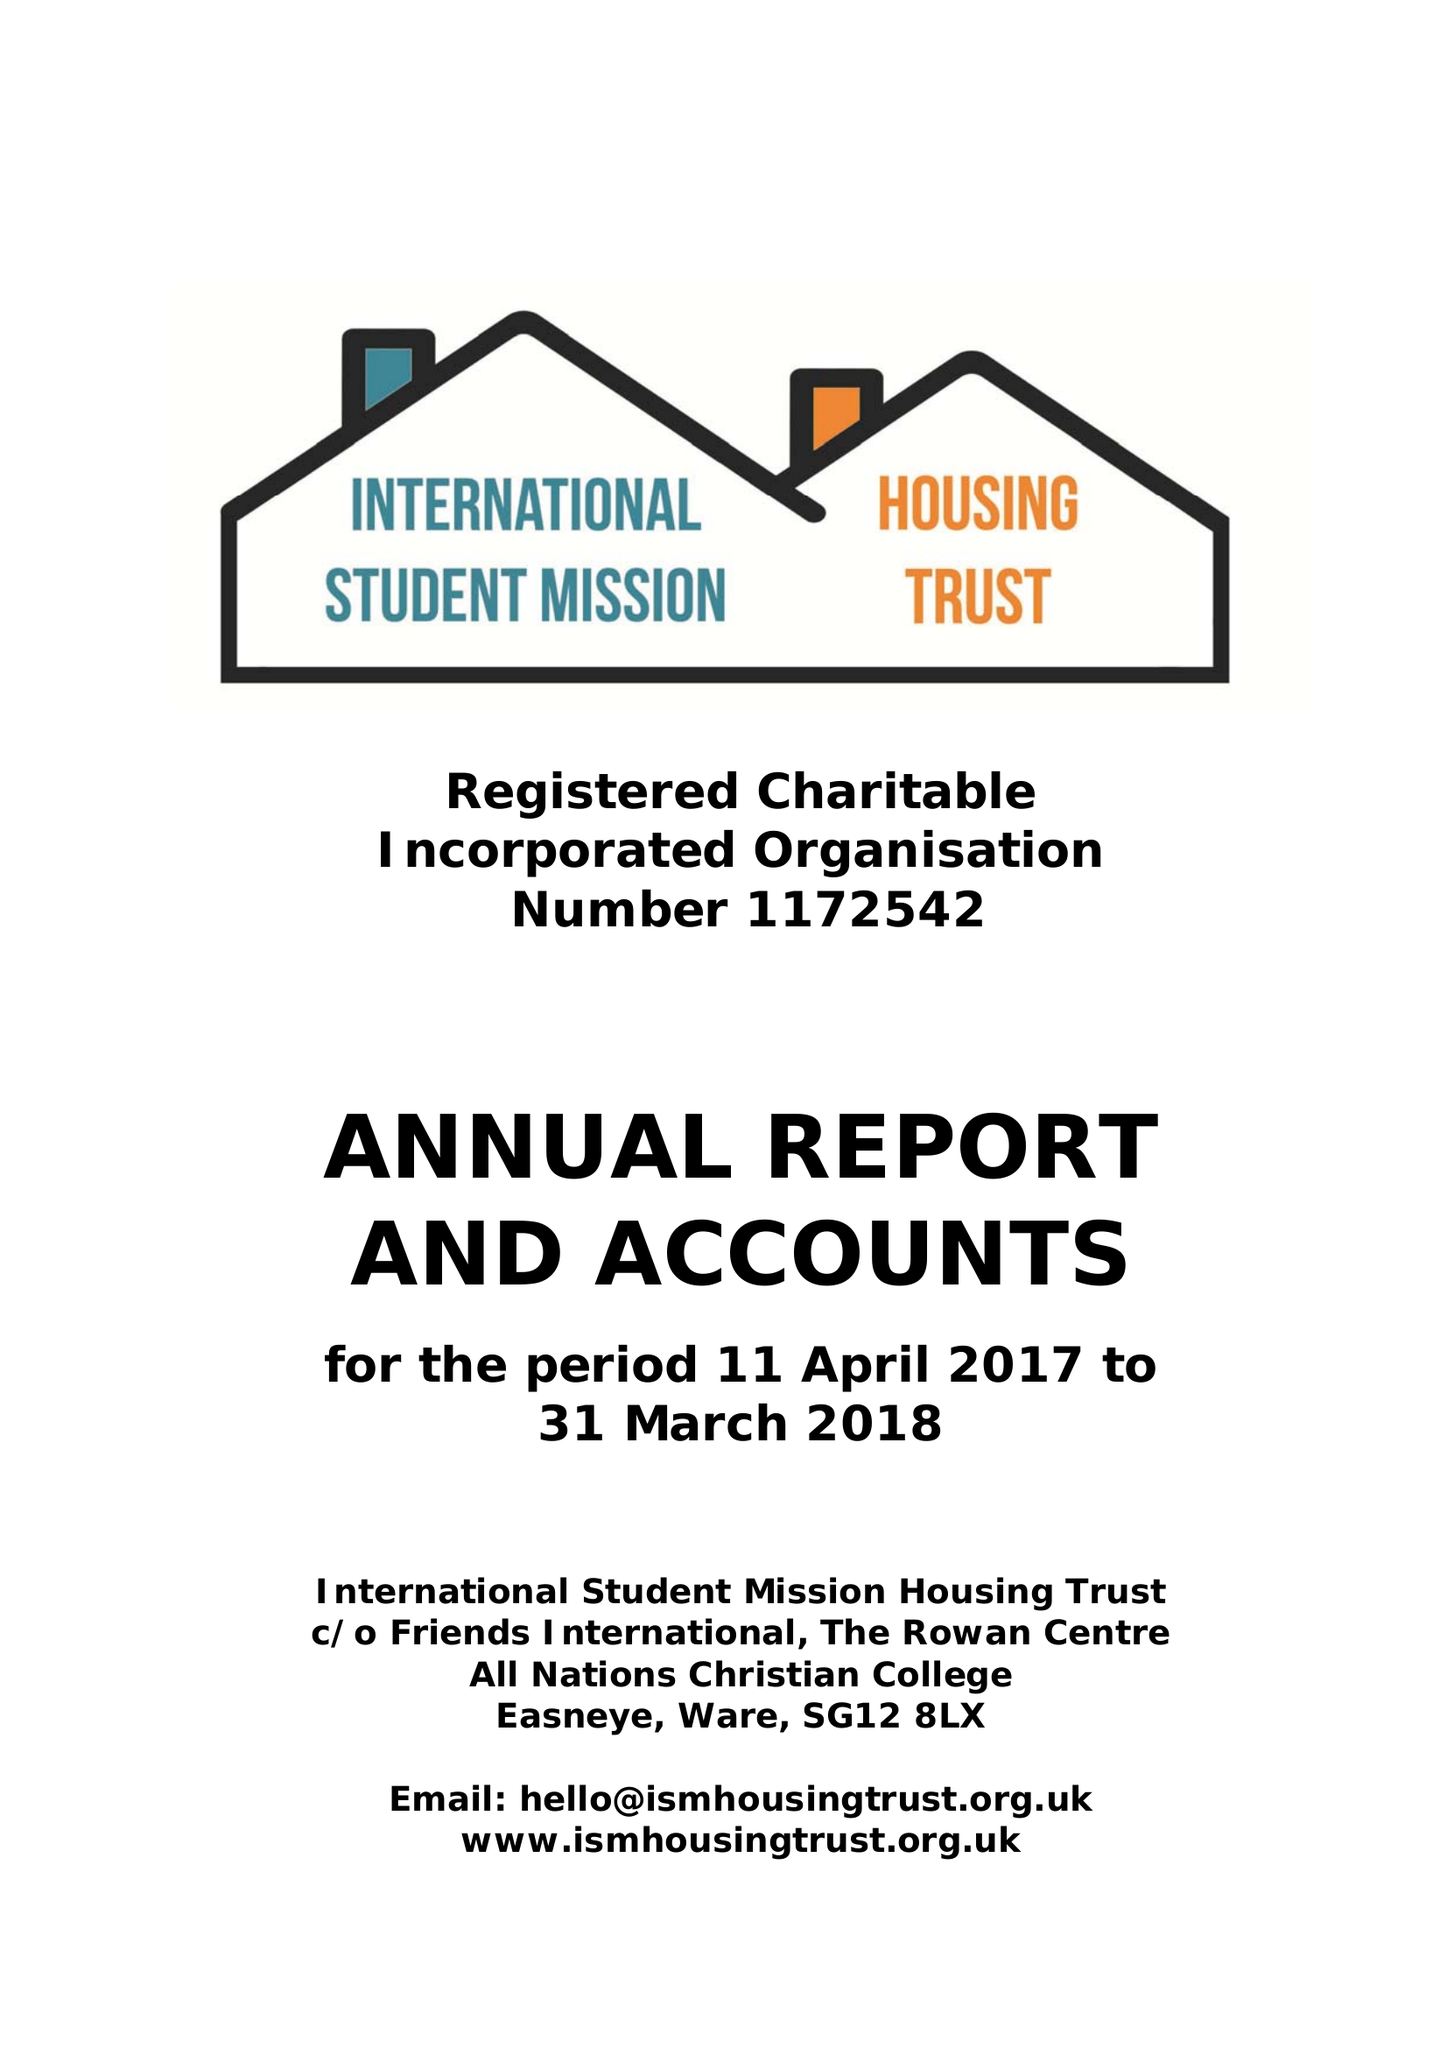What is the value for the address__post_town?
Answer the question using a single word or phrase. WARE 